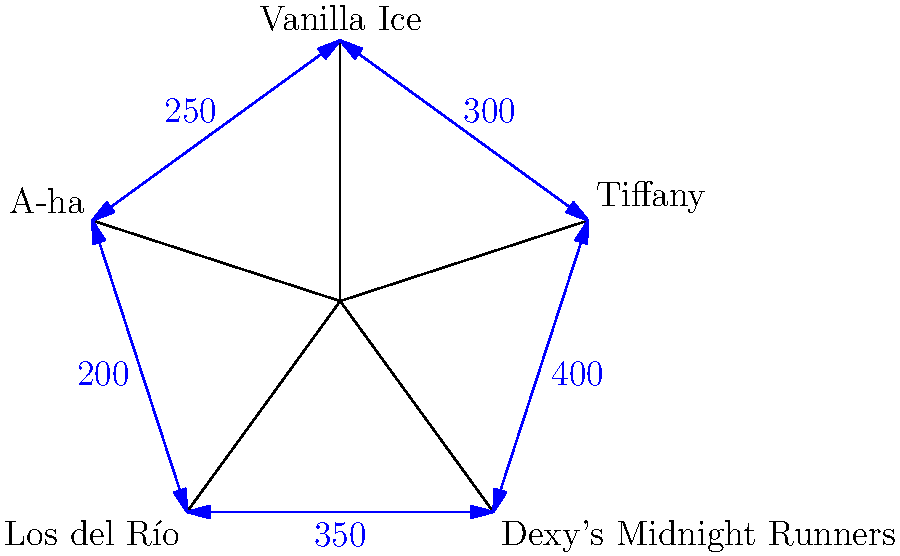At the One-Hit Wonder Intersection, traffic flows clockwise around a star-shaped roundabout named after famous one-hit wonders. Given the traffic flow rates (vehicles per hour) between adjacent streets as shown in the diagram, calculate the total number of vehicles entering the intersection per hour. To solve this problem, we need to sum up all the incoming traffic flows:

1. Tiffany to Vanilla Ice: 300 vehicles/hour
2. Vanilla Ice to A-ha: 250 vehicles/hour
3. A-ha to Los del Río: 200 vehicles/hour
4. Los del Río to Dexy's Midnight Runners: 350 vehicles/hour
5. Dexy's Midnight Runners to Tiffany: 400 vehicles/hour

The total incoming traffic is the sum of these flows:

$$\text{Total} = 300 + 250 + 200 + 350 + 400 = 1500 \text{ vehicles/hour}$$

This calculation assumes that the given flow rates represent the traffic entering the intersection from each street, which is consistent with the clockwise flow indicated in the question.
Answer: 1500 vehicles/hour 